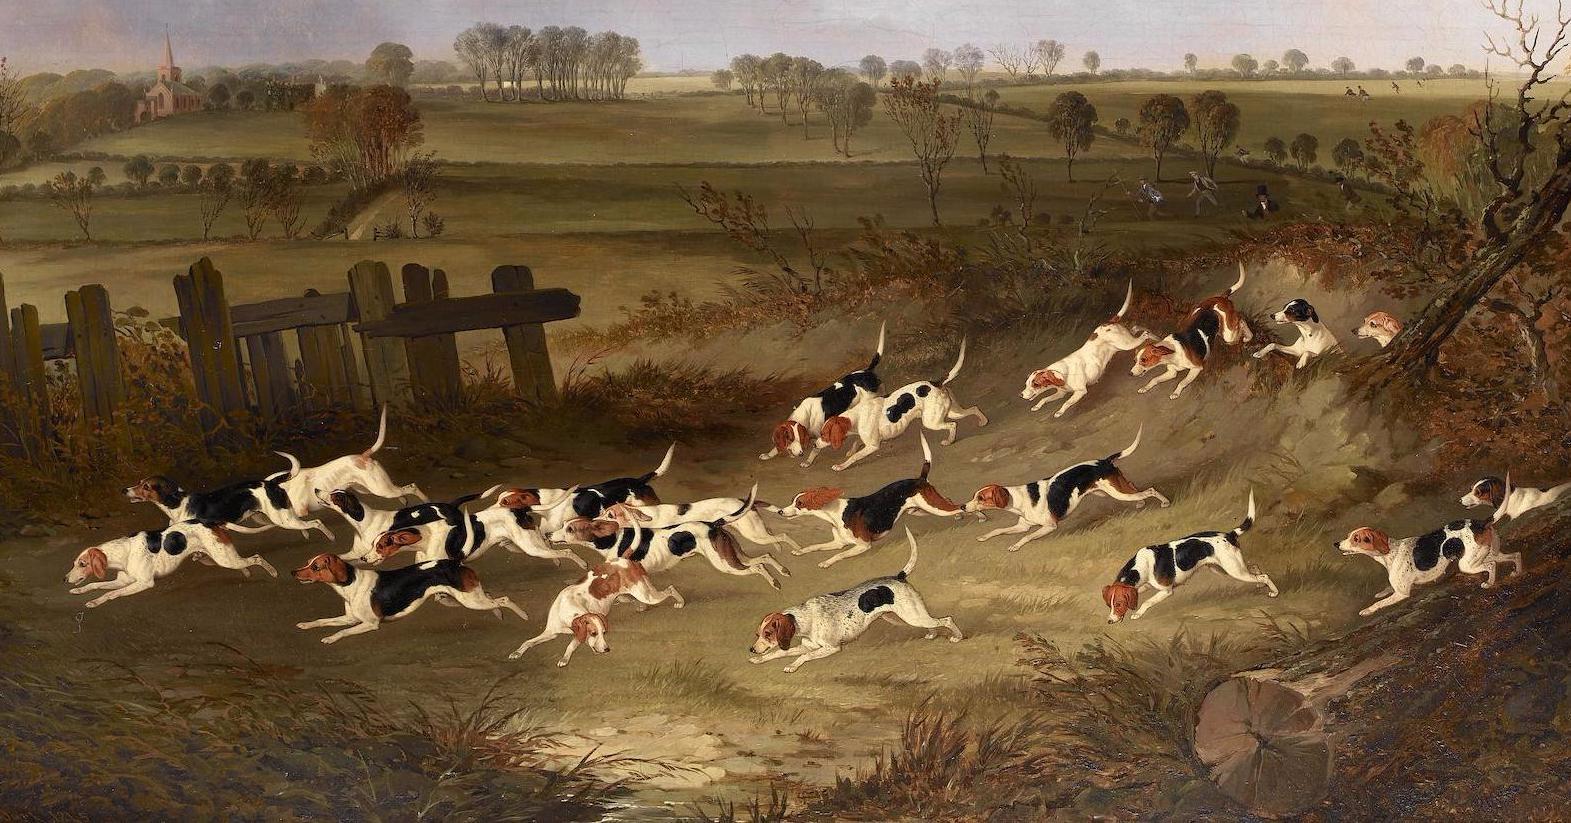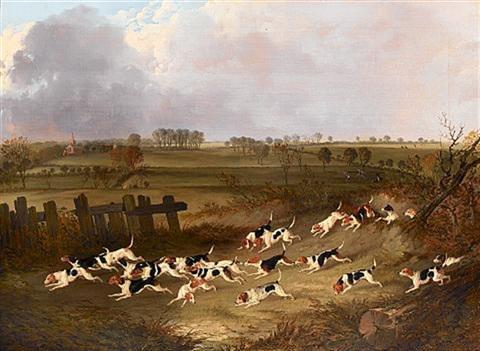The first image is the image on the left, the second image is the image on the right. Examine the images to the left and right. Is the description "There are no more than three animals in the image on the right" accurate? Answer yes or no. No. 